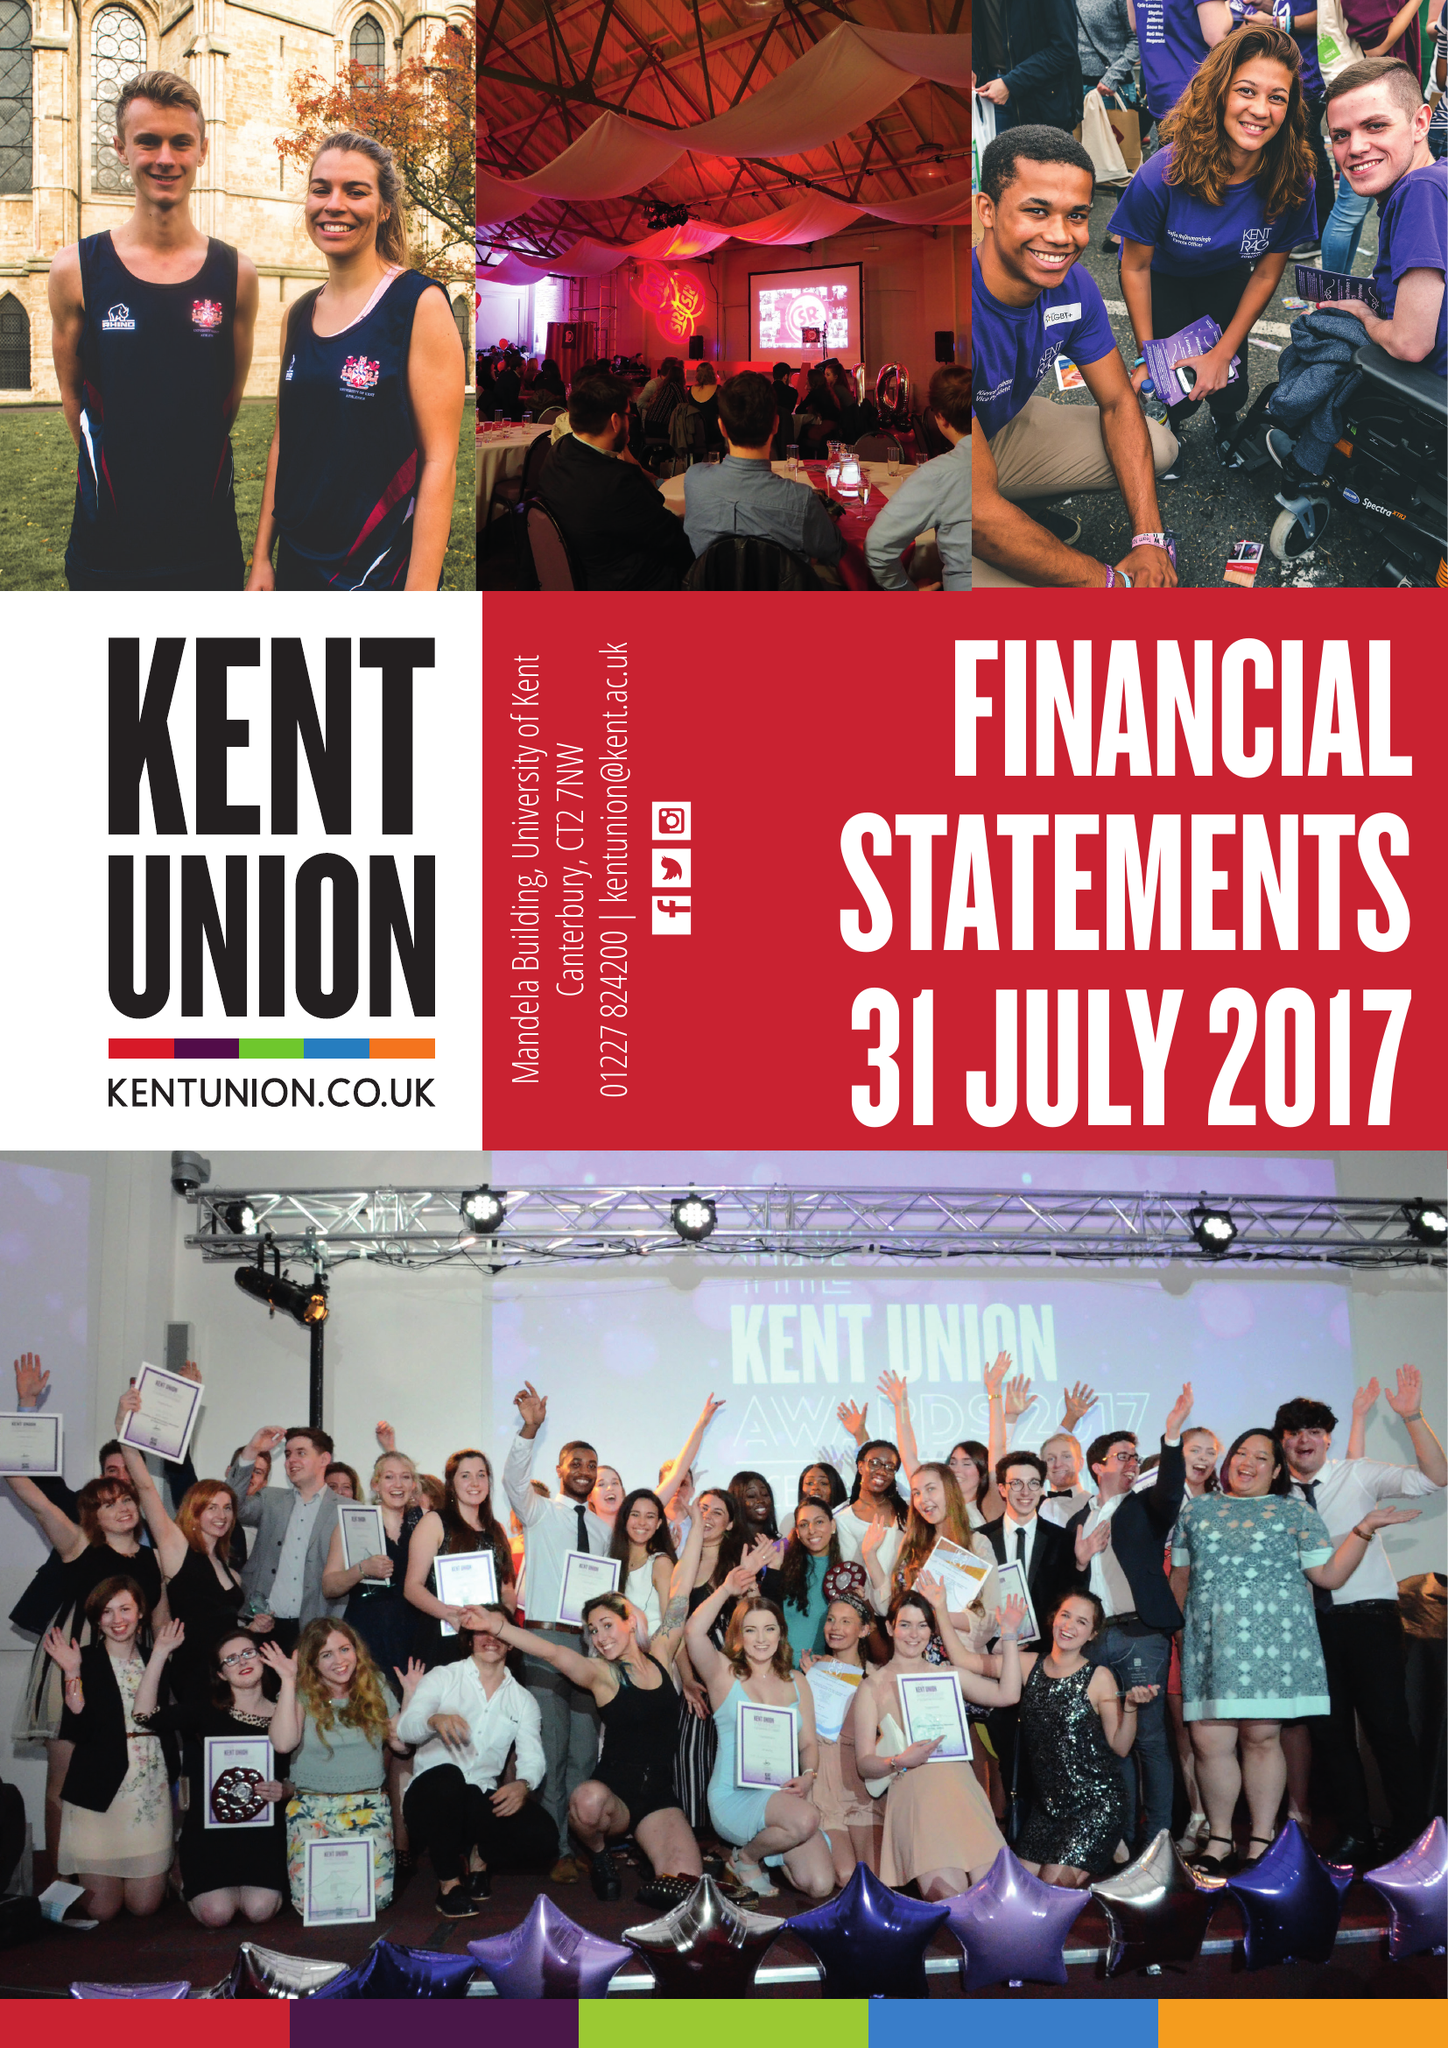What is the value for the charity_name?
Answer the question using a single word or phrase. Kent Union 